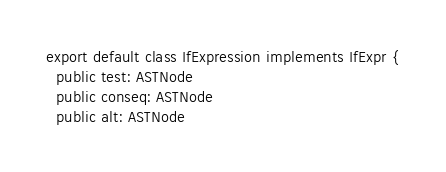<code> <loc_0><loc_0><loc_500><loc_500><_TypeScript_>export default class IfExpression implements IfExpr {
  public test: ASTNode
  public conseq: ASTNode
  public alt: ASTNode
</code> 